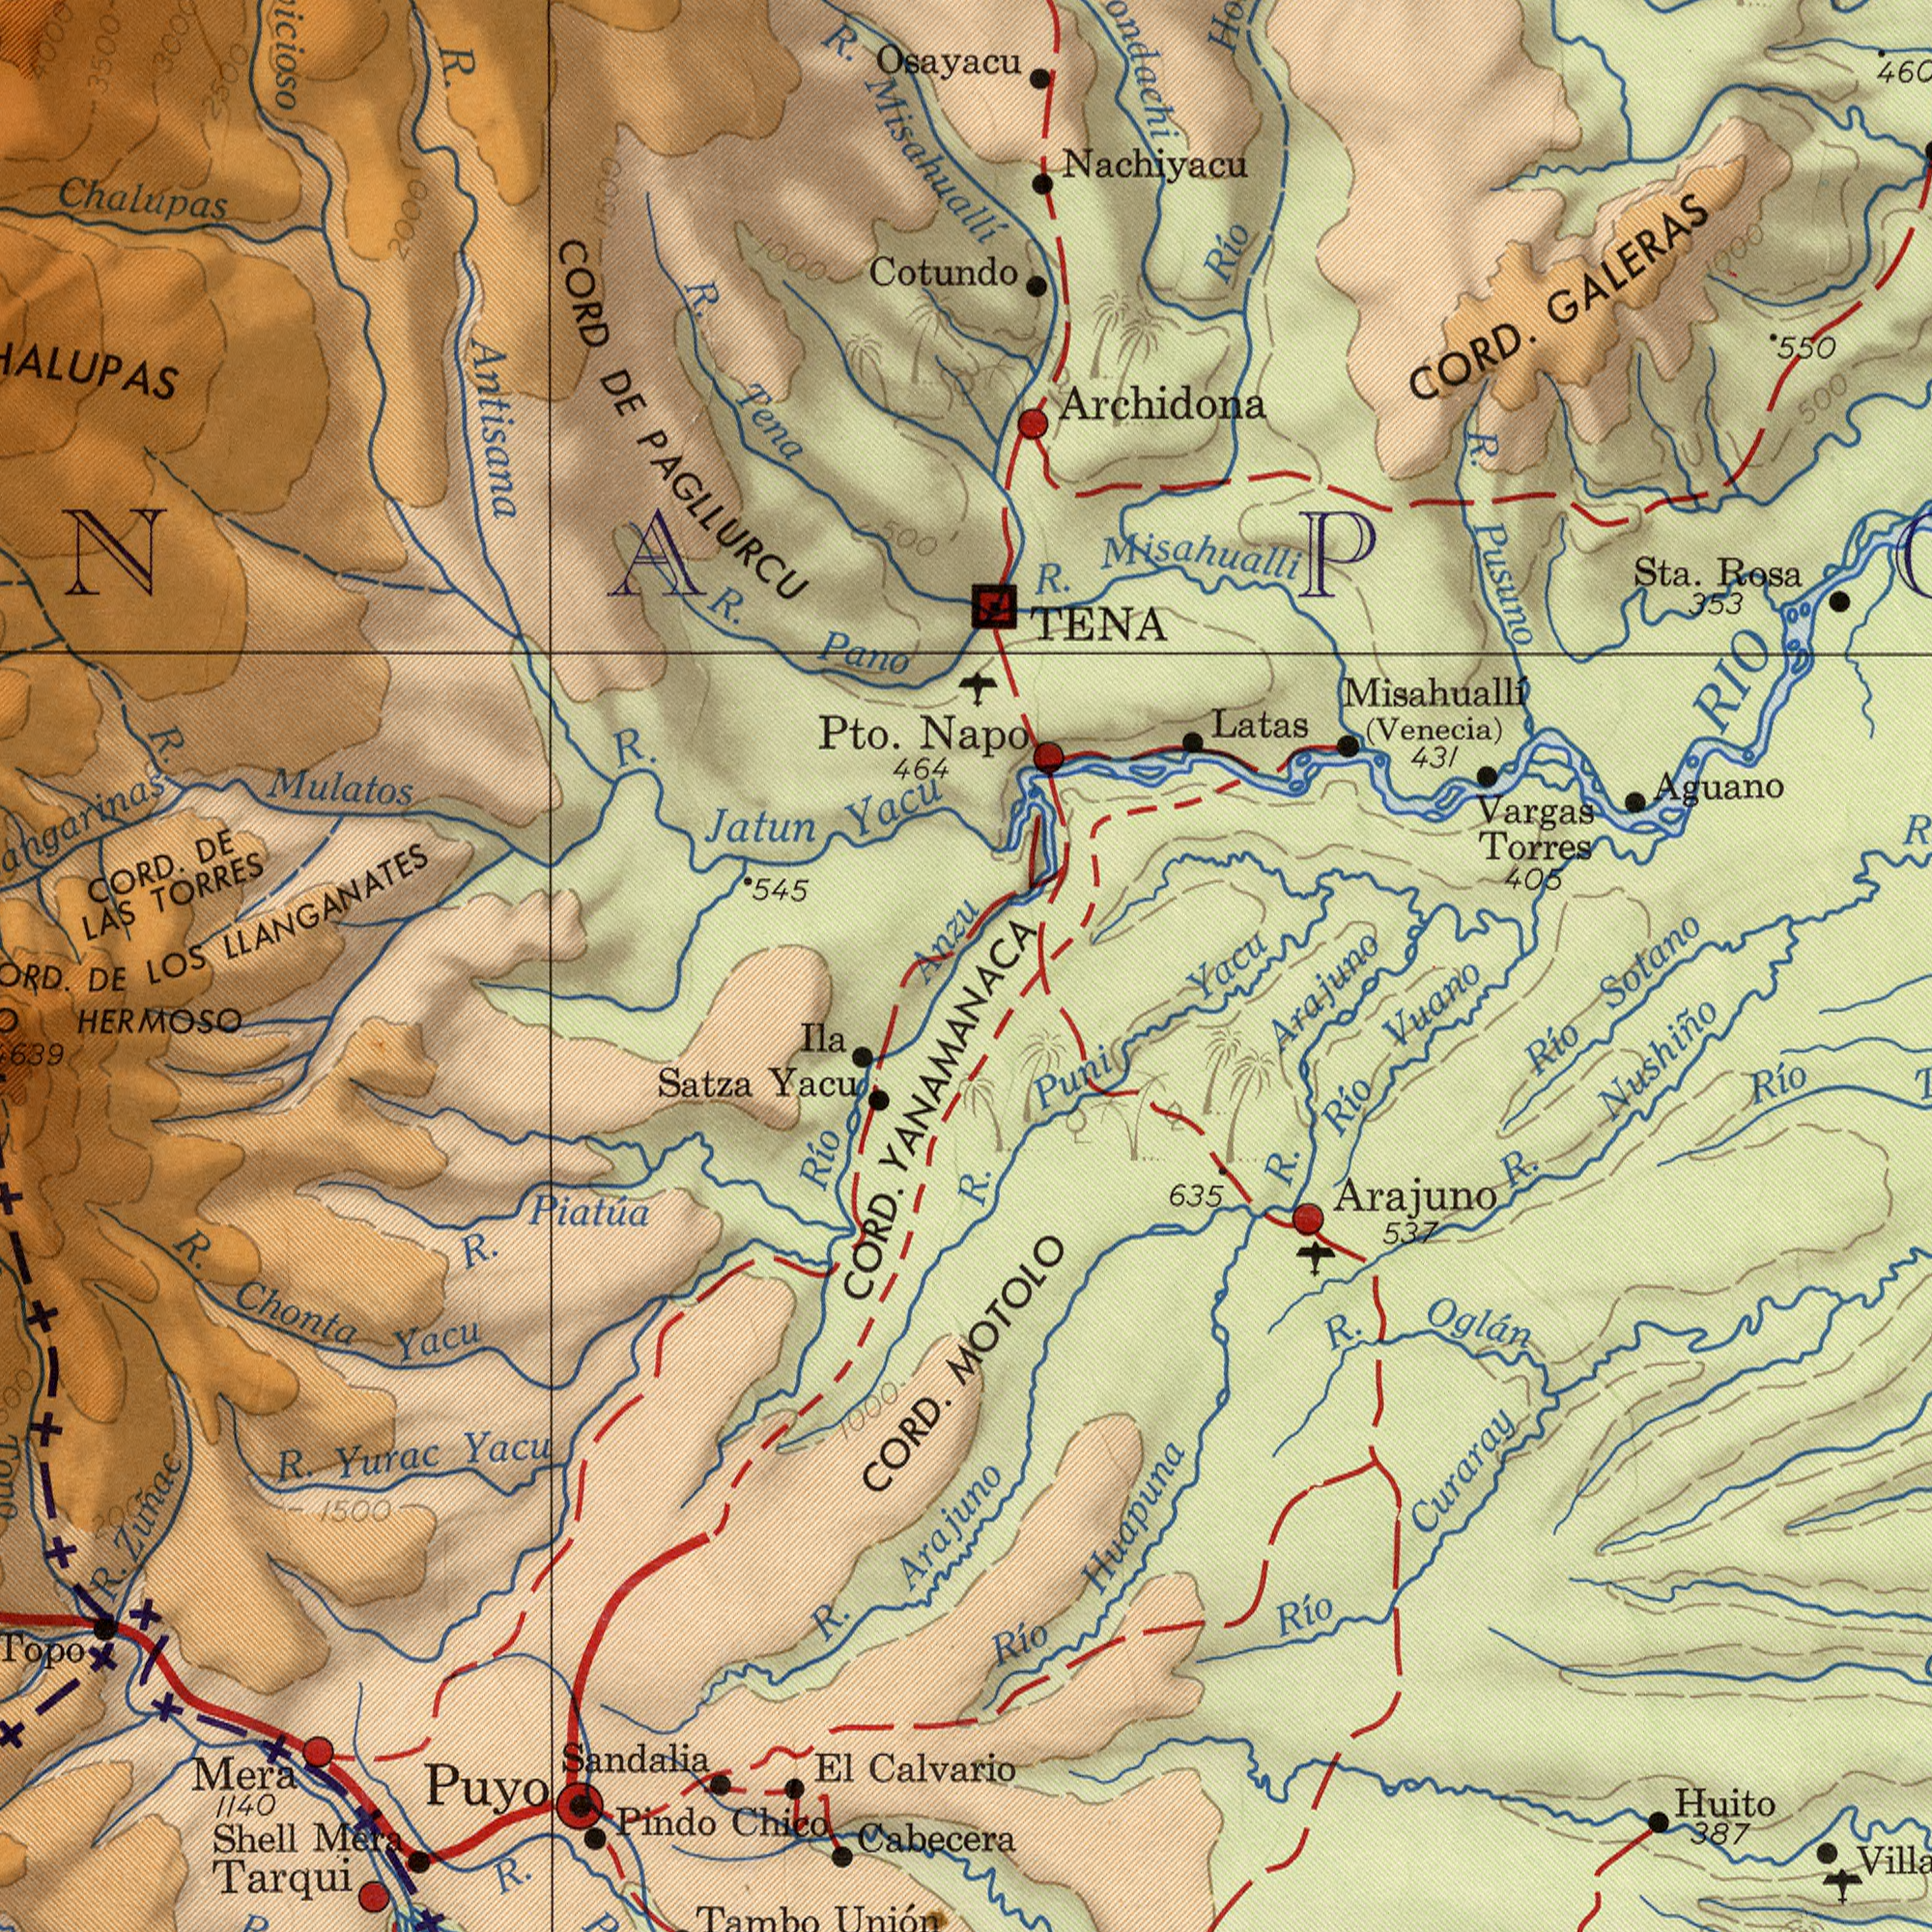What text appears in the bottom-left area of the image? HERMOSO Tarqui Sandalia R. R. Mera Satza Pindo R. R. Piatúa Yacu Shell Chico Yurac CORD. Yacu CORD. Cabecera Yacu Unión Puyo Ila El 1500 Calvario Topo Río Tambo DE 1000 Zuñac R. R. Mera Chonta 1140 639 YANAMANACA 2000 Arajuno What text appears in the top-left area of the image? Antisana Mulatos TORRES CORD CORD. R. Chalupas Pto. PAGLLURCU LLANGANATES Pano Yacu Osayacu R. LAS R. Jatun Misahuallí 464 R. DE 2000 Tena 545 500 DE 1000 Cotundo R. R. 4000 3500 3000 2500 Anzu 1500 LOS What text appears in the top-right area of the image? Napo Misahualli Misahuallí Nachiyacu R. GALERAS Pusuno Torres TENA Archidona Aguano 550 Rosa Río R. CORD. Sta. 431 (Venecia) 460 Vargas Latas 405 500 353 1000 RIO Yacu Sotano What text is visible in the lower-right corner? Huapuna Nushiño Arajuno Huito Río Puni R. Río 387 Río Río R. R. Río 635 Oglán 537 Curaray R. Vuano Arajuno MOTOLO 